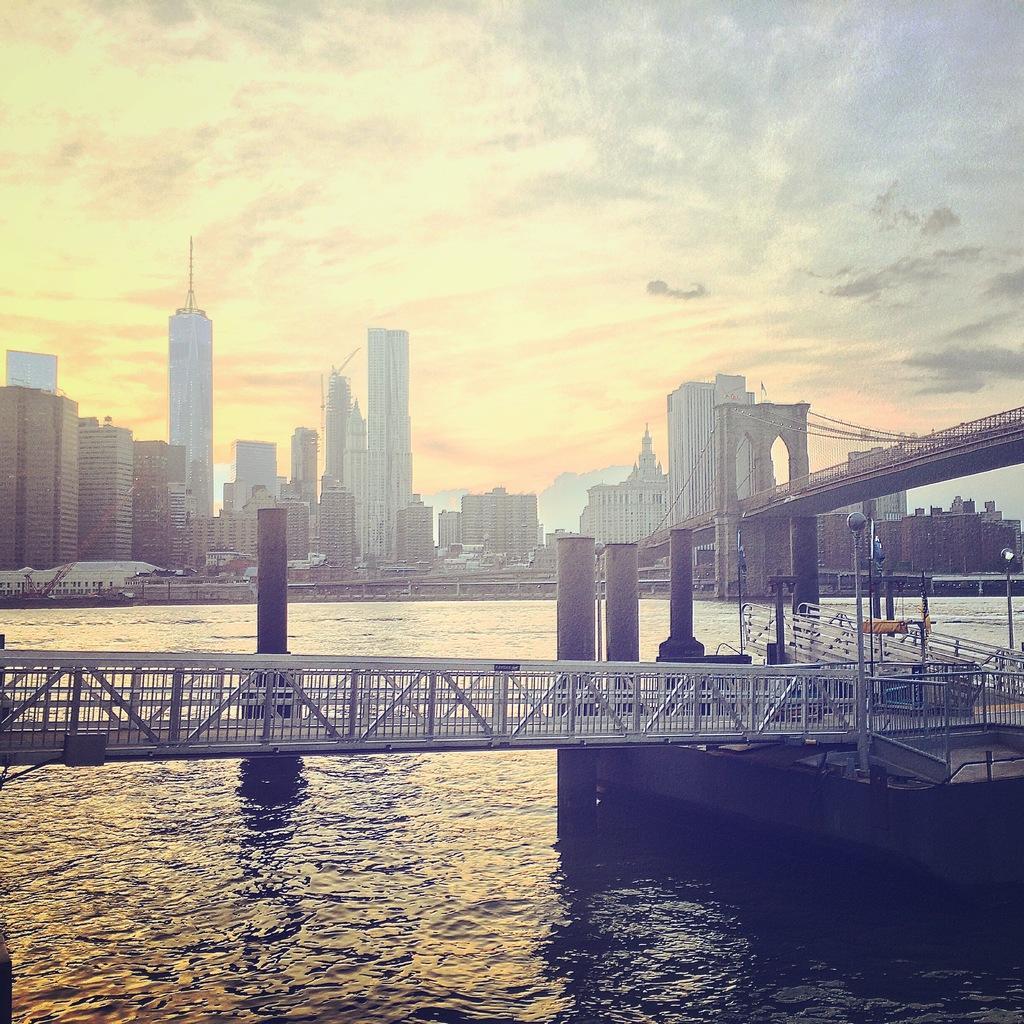Please provide a concise description of this image. In this image we can see a bridge, water. In the background of the image there are buildings, sky, clouds. 